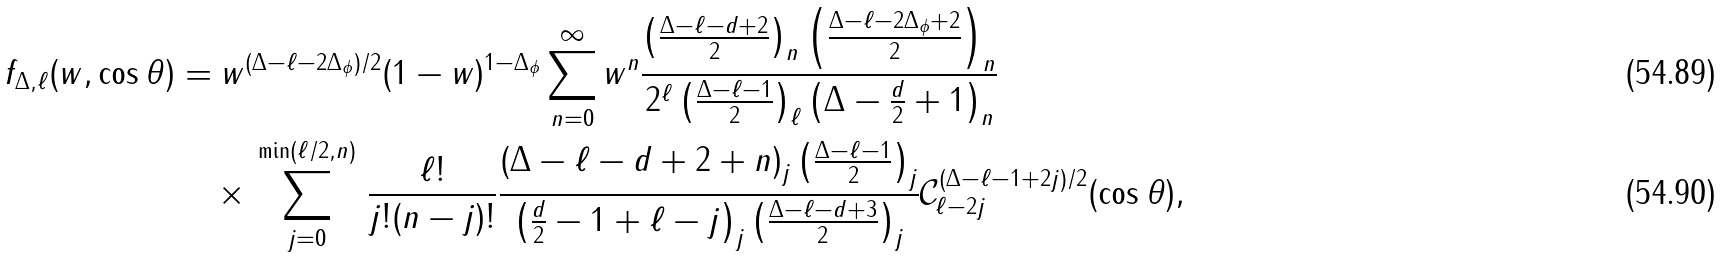Convert formula to latex. <formula><loc_0><loc_0><loc_500><loc_500>f _ { \Delta , \ell } ( w , \cos \theta ) & = w ^ { ( \Delta - \ell - 2 \Delta _ { \phi } ) / 2 } ( 1 - w ) ^ { 1 - \Delta _ { \phi } } \sum _ { n = 0 } ^ { \infty } w ^ { n } \frac { \left ( \frac { \Delta - \ell - d + 2 } { 2 } \right ) _ { n } \left ( \frac { \Delta - \ell - 2 \Delta _ { \phi } + 2 } { 2 } \right ) _ { n } } { 2 ^ { \ell } \left ( \frac { \Delta - \ell - 1 } { 2 } \right ) _ { \ell } \left ( \Delta - \frac { d } { 2 } + 1 \right ) _ { n } } \\ & \quad \times \, \sum _ { j = 0 } ^ { \min ( \ell / 2 , n ) } \, \frac { \ell ! } { j ! ( n - j ) ! } \frac { \left ( \Delta - \ell - d + 2 + n \right ) _ { j } \left ( \frac { \Delta - \ell - 1 } { 2 } \right ) _ { j } } { \left ( \frac { d } { 2 } - 1 + \ell - j \right ) _ { j } \left ( \frac { \Delta - \ell - d + 3 } { 2 } \right ) _ { j } } \mathcal { C } _ { \ell - 2 j } ^ { ( \Delta - \ell - 1 + 2 j ) / 2 } ( \cos \theta ) ,</formula> 